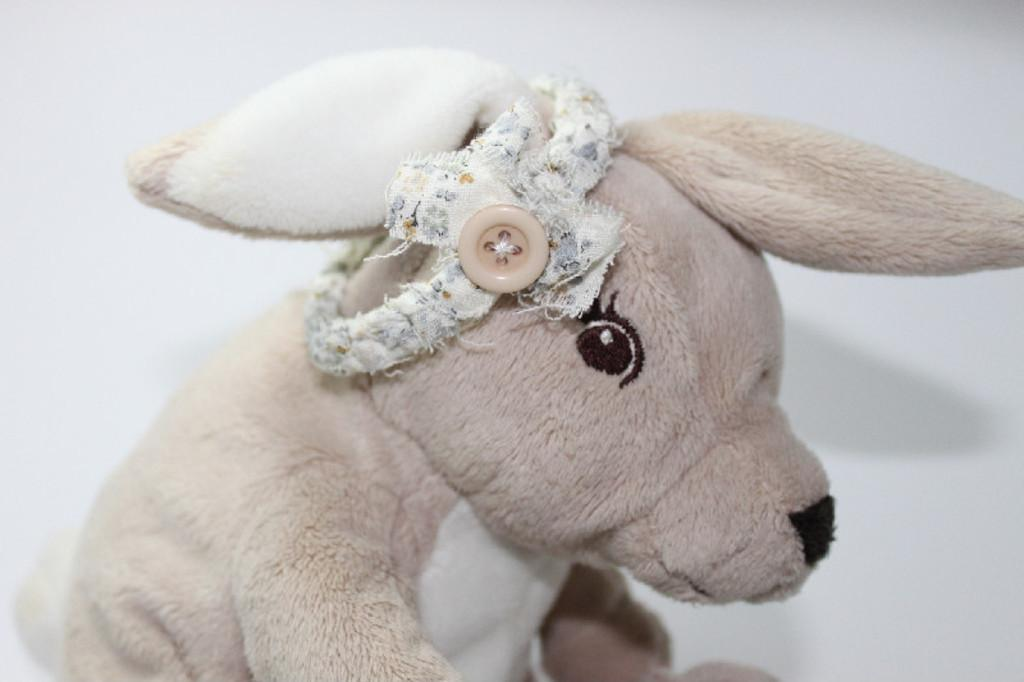What type of object can be seen in the picture? There is a soft toy in the picture. What color is the background of the image? The background of the image is white. How many teeth can be seen on the soft toy in the image? There are no teeth visible on the soft toy in the image, as soft toys typically do not have teeth. 